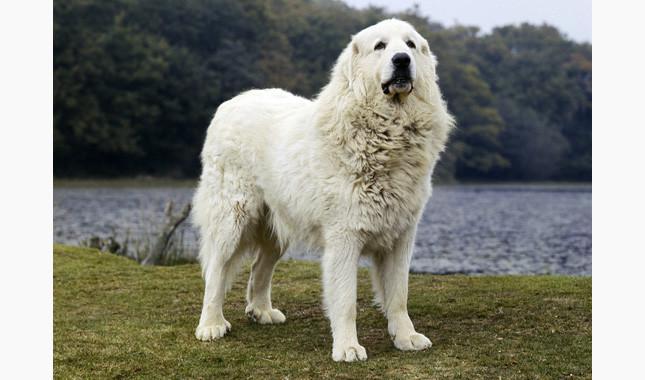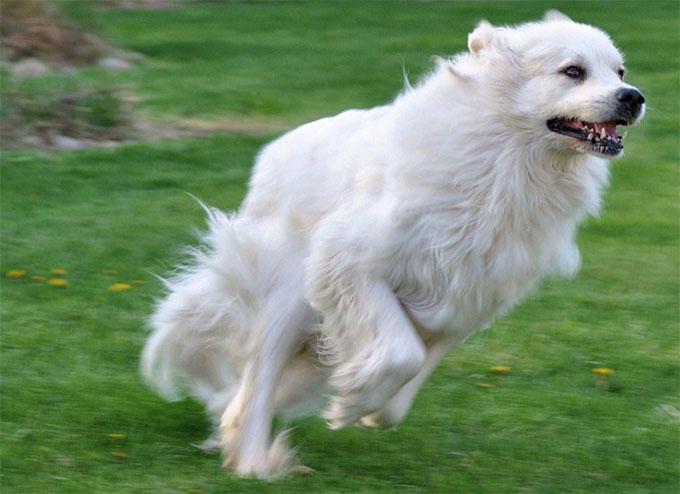The first image is the image on the left, the second image is the image on the right. Examine the images to the left and right. Is the description "There are two dogs in the image pair, both facing the same direction as the other." accurate? Answer yes or no. Yes. The first image is the image on the left, the second image is the image on the right. Considering the images on both sides, is "An image contains one white dog standing in profile and turned leftward." valid? Answer yes or no. No. 